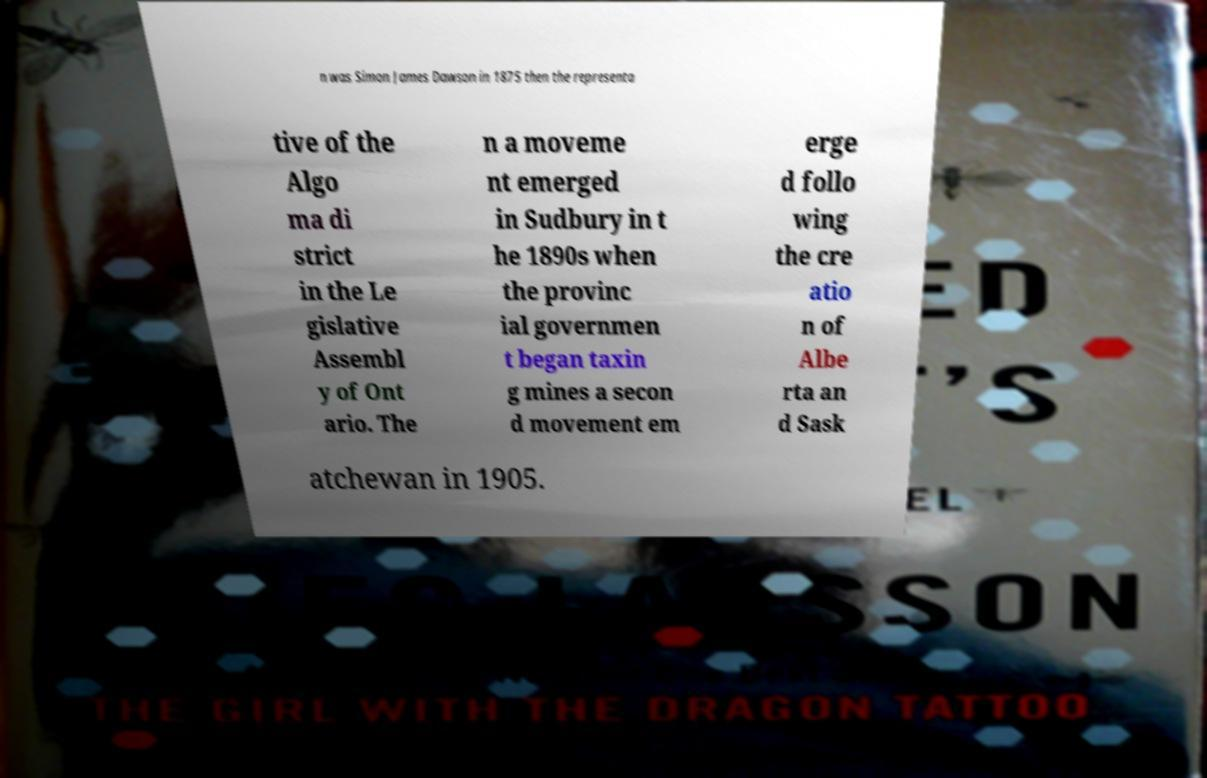Can you read and provide the text displayed in the image?This photo seems to have some interesting text. Can you extract and type it out for me? n was Simon James Dawson in 1875 then the representa tive of the Algo ma di strict in the Le gislative Assembl y of Ont ario. The n a moveme nt emerged in Sudbury in t he 1890s when the provinc ial governmen t began taxin g mines a secon d movement em erge d follo wing the cre atio n of Albe rta an d Sask atchewan in 1905. 